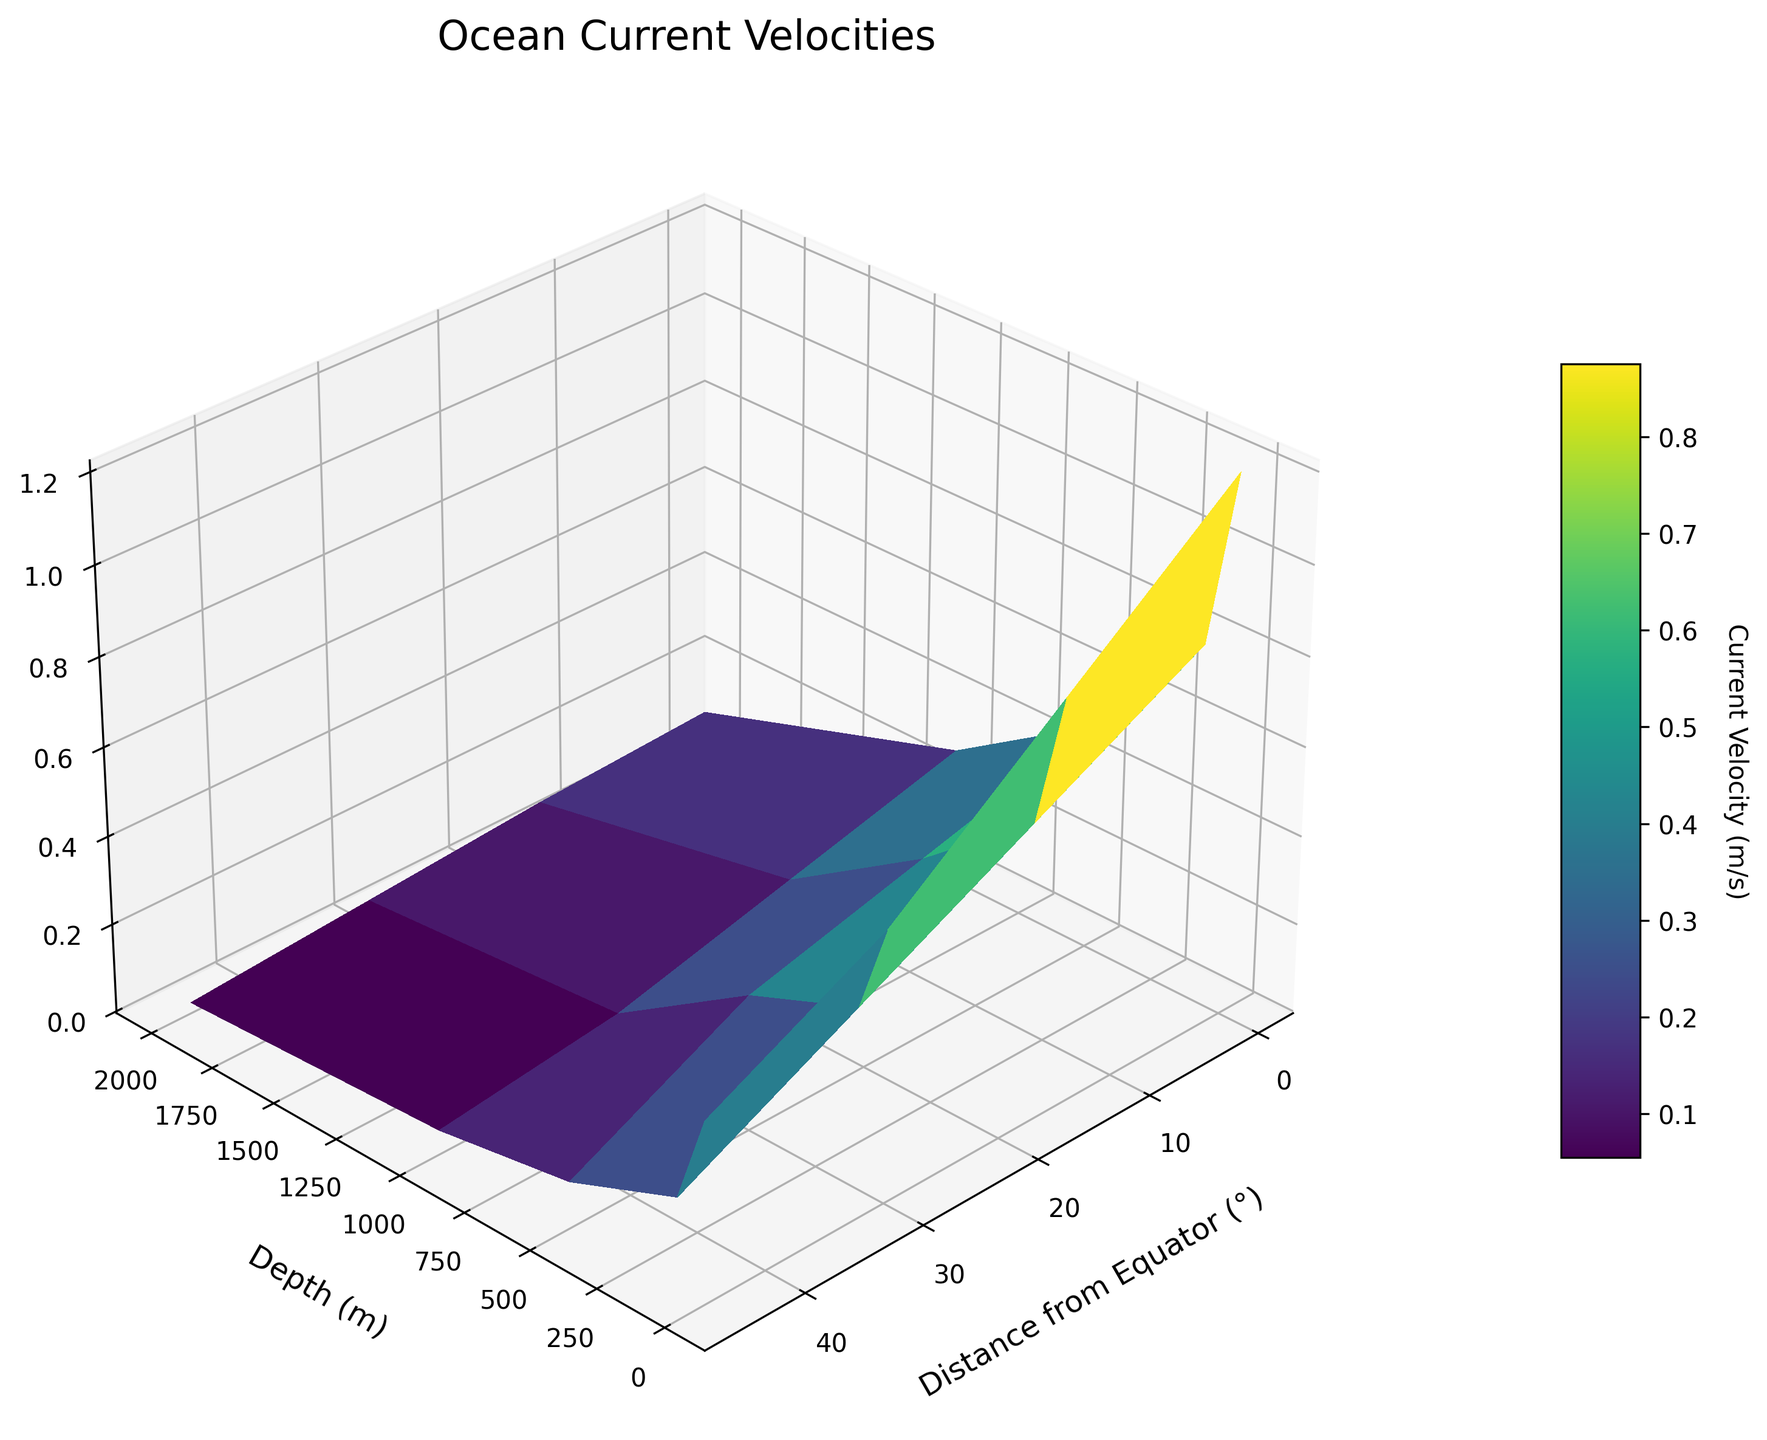What is the title of the 3D surface plot? The title of the figure is displayed prominently at the top of the plot. By observing the figure, we can see the text that serves as the title.
Answer: Ocean Current Velocities How many depth levels are plotted on the figure? By looking at the y-axis label "Depth (m)" and counting the distinct levels indicated along this axis, we can determine the number of different depths plotted.
Answer: 5 At what depth does the current velocity first drop below 0.5 m/s at the equator? To answer this, observe the current velocities along the distance = 0° and identify the depth at which the value first drops below 0.5 m/s. From the depth values (0 m: 1.2 m/s, 100 m: 0.8 m/s, 500 m: 0.5 m/s, 1000 m: 0.3 m/s), the drop occurs at 1000 m.
Answer: 1000 m What is the current velocity at a depth of 500 m and 30° from the equator? Locate the coordinates (500 m depth, 30° distance) on the plot and read the corresponding current velocity value from the surface.
Answer: 0.3 m/s How does current velocity generally change with depth? By observing the surface plot, current velocities tend to decrease as depth increases. Indicating that deeper ocean currents generally move slower.
Answer: Decreases Compare the current velocities at 0 m and 2000 m depths at 15° from the equator. Which is greater, and by how much? Find the current velocities at 0 m depth (0.9 m/s) and 2000 m depth (0.08 m/s) at 15° from the equator. Subtract the 2000 m value from the 0 m value to get the difference.
Answer: 0 m depth is greater by 0.82 m/s What is the average current velocity at a depth of 0 m across all distances from the equator? Identify the values at 0 m depth (1.2, 0.9, 0.6, 0.4 m/s) and calculate their average: (1.2 + 0.9 + 0.6 + 0.4) / 4 = 0.775 m/s.
Answer: 0.775 m/s How does the current velocity pattern change from 0 m to 1000 m depth at the equator? Observe the current velocities along the equator (distance = 0°): 1.2 m/s at 0 m, 0.8 m/s at 100 m, 0.5 m/s at 500 m, 0.3 m/s at 1000 m, and note the trend.
Answer: Steady decrease Which area shows the lowest current velocity on the surface plot? By scanning the surface plot, identify the region with the minimum altitude/color intensity; it occurs at the greatest depth and farthest distance from the equator (2000 m, 45°: 0.02 m/s).
Answer: 2000 m depth, 45° What can you infer about the relationship between distance from the equator and current velocity at different depths? Analyze the surface plot to see trends: current velocity decreases as both distance from the equator and depth increase. This indicates an overall pattern where distance from the equator generally slows down ocean currents at various depths.
Answer: Decreases 